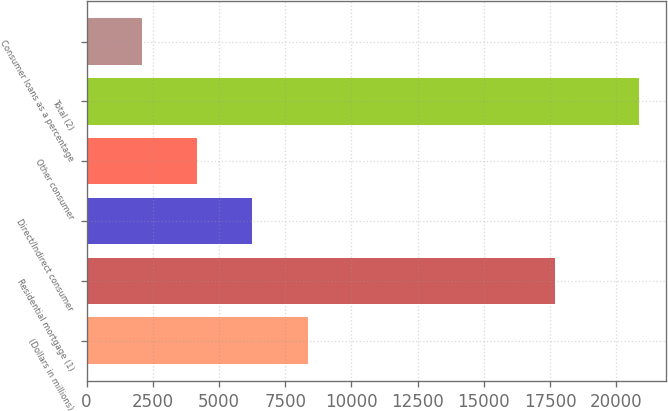<chart> <loc_0><loc_0><loc_500><loc_500><bar_chart><fcel>(Dollars in millions)<fcel>Residential mortgage (1)<fcel>Direct/Indirect consumer<fcel>Other consumer<fcel>Total (2)<fcel>Consumer loans as a percentage<nl><fcel>8343.56<fcel>17691<fcel>6258.48<fcel>4173.4<fcel>20854<fcel>2088.32<nl></chart> 